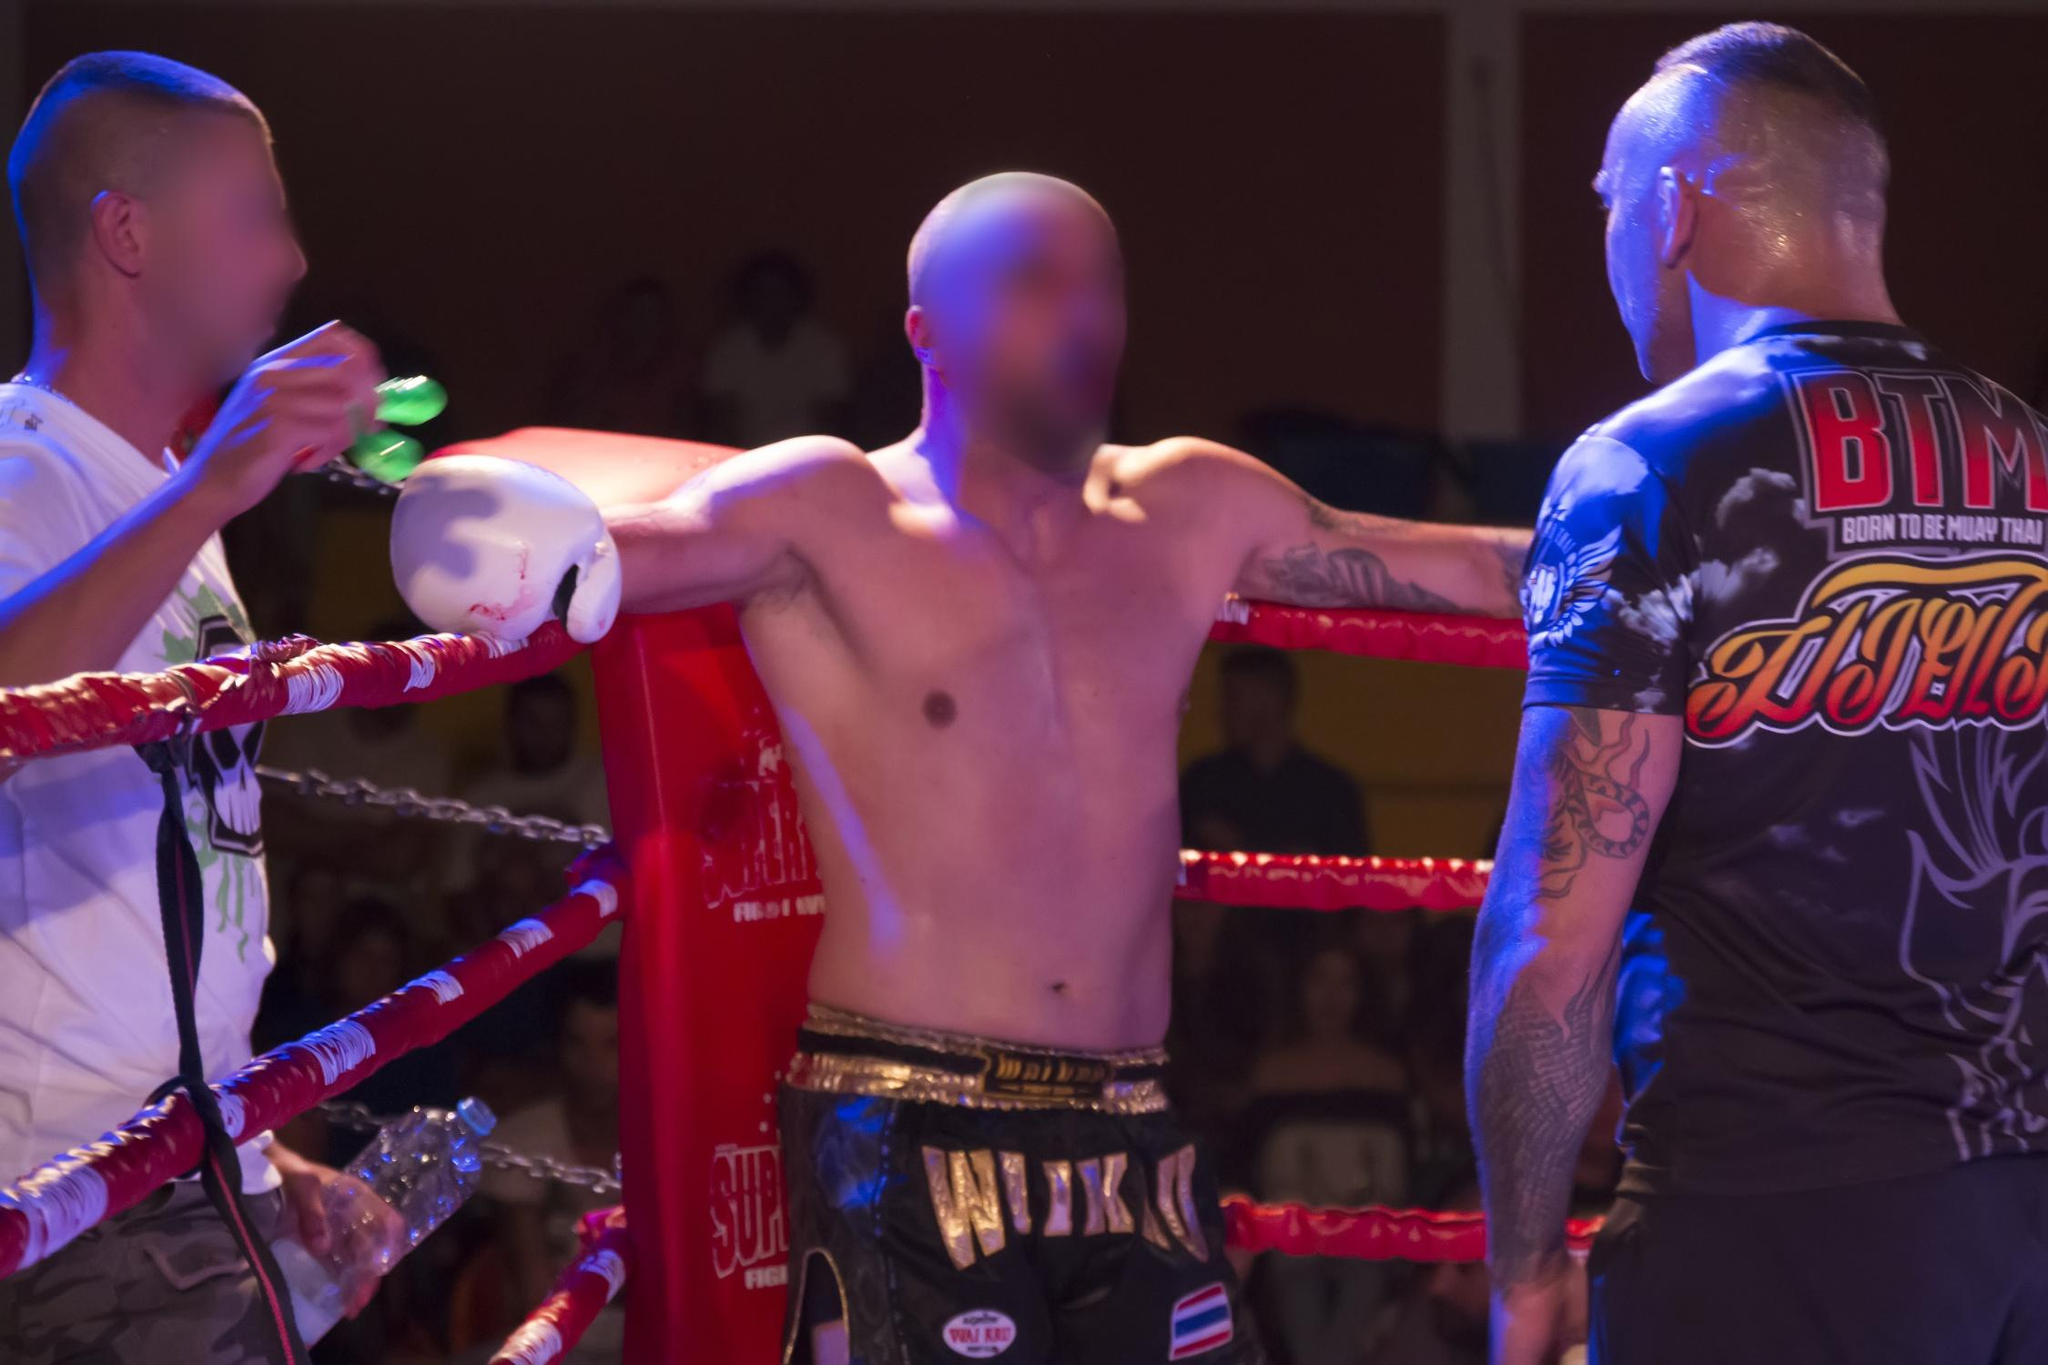What do the physical expressions and body language of the boxer suggest about his current state during the match? The boxer's body language, with arms resting and outstretched on the ropes and an upright posture, suggests a moment of rest and recuperation indicating fatigue or a strategic pause in the action. His focus towards the coach and the direct interaction indicate concentration and mental preparation, possibly reflecting on the advice given or bracing for the challenges of upcoming rounds. This posture and interaction typically represent a critical reassessment period within the match, where physical and mental resilience are recalibrated for continued competition. 